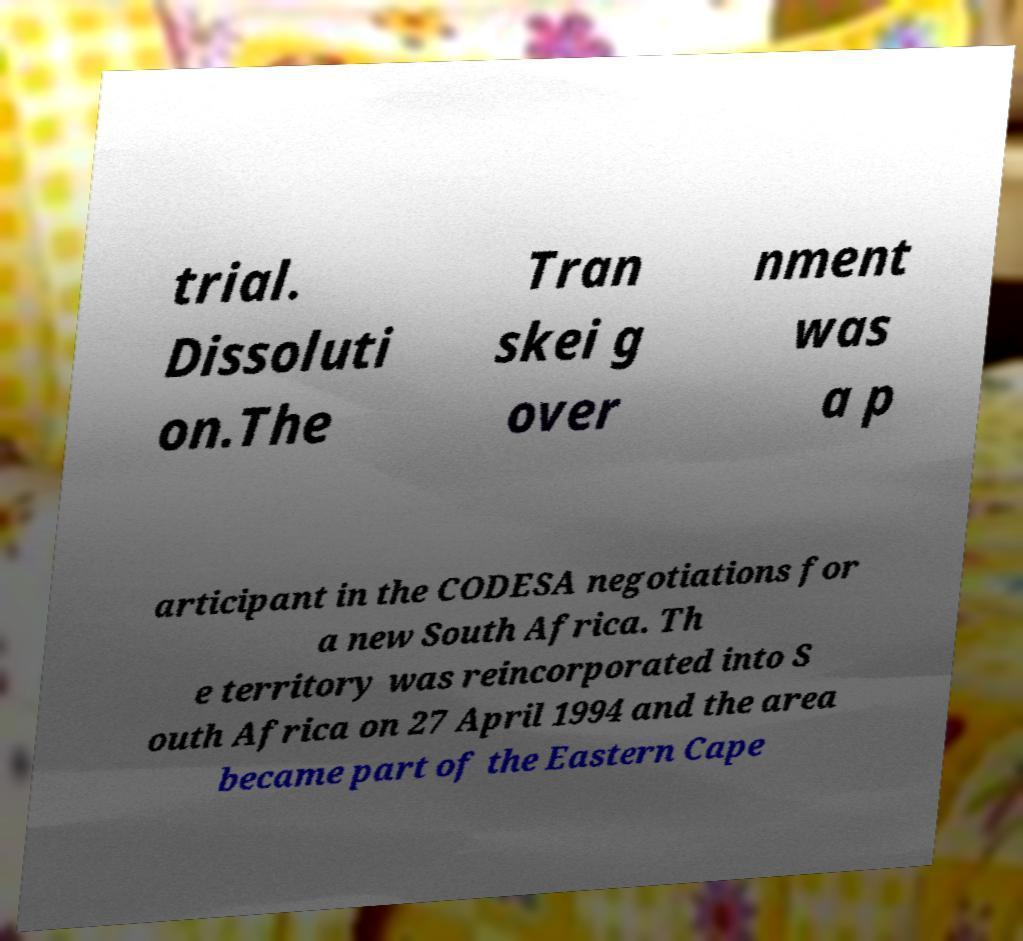Could you extract and type out the text from this image? trial. Dissoluti on.The Tran skei g over nment was a p articipant in the CODESA negotiations for a new South Africa. Th e territory was reincorporated into S outh Africa on 27 April 1994 and the area became part of the Eastern Cape 